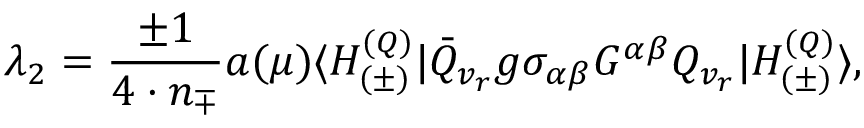Convert formula to latex. <formula><loc_0><loc_0><loc_500><loc_500>\lambda _ { 2 } = \frac { \pm 1 } { 4 \cdot n _ { \mp } } a ( \mu ) \langle H _ { ( \pm ) } ^ { ( Q ) } | \bar { Q } _ { v _ { r } } g \sigma _ { \alpha \beta } G ^ { \alpha \beta } Q _ { v _ { r } } | H _ { ( \pm ) } ^ { ( Q ) } \rangle ,</formula> 